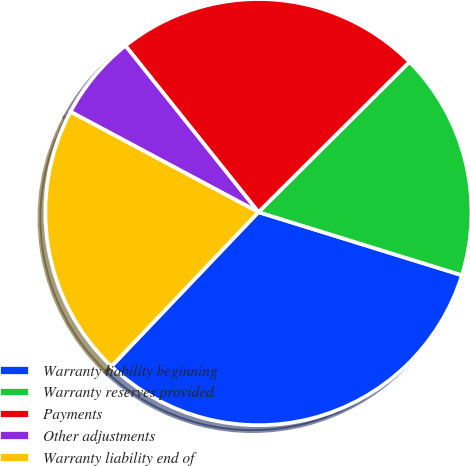<chart> <loc_0><loc_0><loc_500><loc_500><pie_chart><fcel>Warranty liability beginning<fcel>Warranty reserves provided<fcel>Payments<fcel>Other adjustments<fcel>Warranty liability end of<nl><fcel>32.33%<fcel>17.25%<fcel>23.27%<fcel>6.46%<fcel>20.69%<nl></chart> 